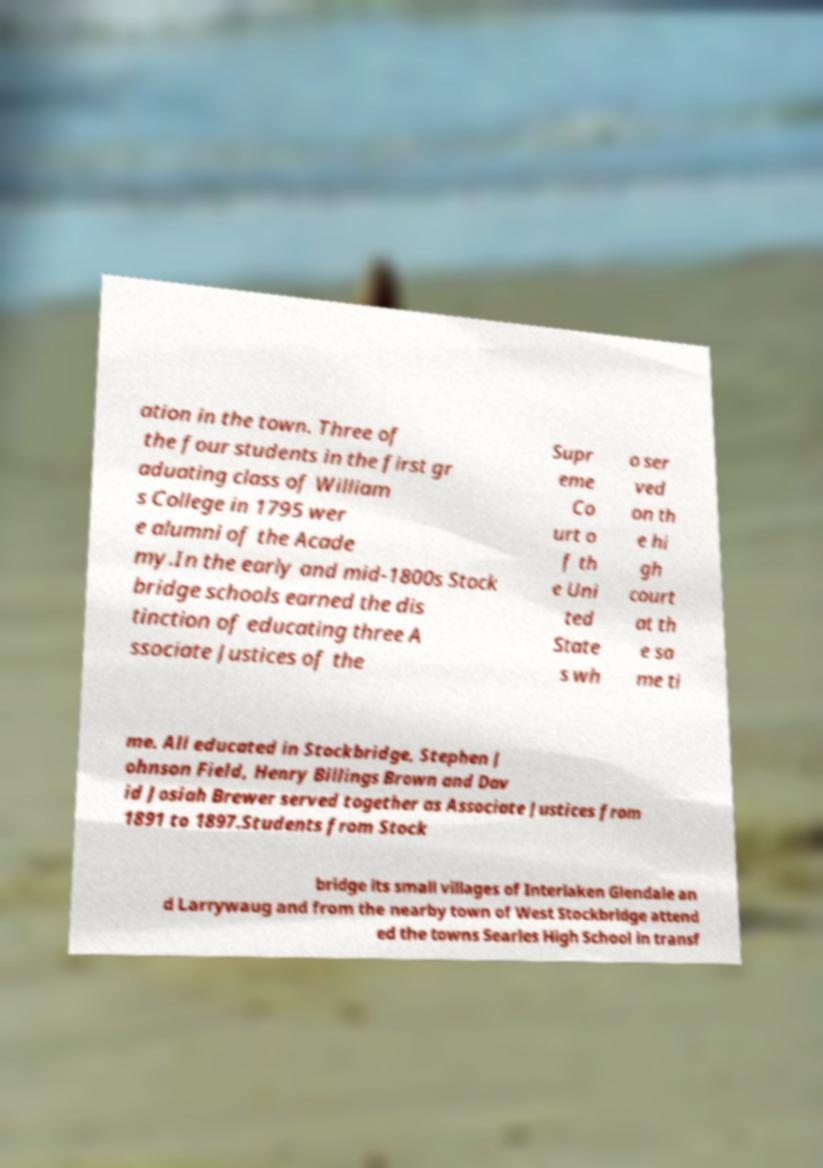For documentation purposes, I need the text within this image transcribed. Could you provide that? ation in the town. Three of the four students in the first gr aduating class of William s College in 1795 wer e alumni of the Acade my.In the early and mid-1800s Stock bridge schools earned the dis tinction of educating three A ssociate Justices of the Supr eme Co urt o f th e Uni ted State s wh o ser ved on th e hi gh court at th e sa me ti me. All educated in Stockbridge, Stephen J ohnson Field, Henry Billings Brown and Dav id Josiah Brewer served together as Associate Justices from 1891 to 1897.Students from Stock bridge its small villages of Interlaken Glendale an d Larrywaug and from the nearby town of West Stockbridge attend ed the towns Searles High School in transf 